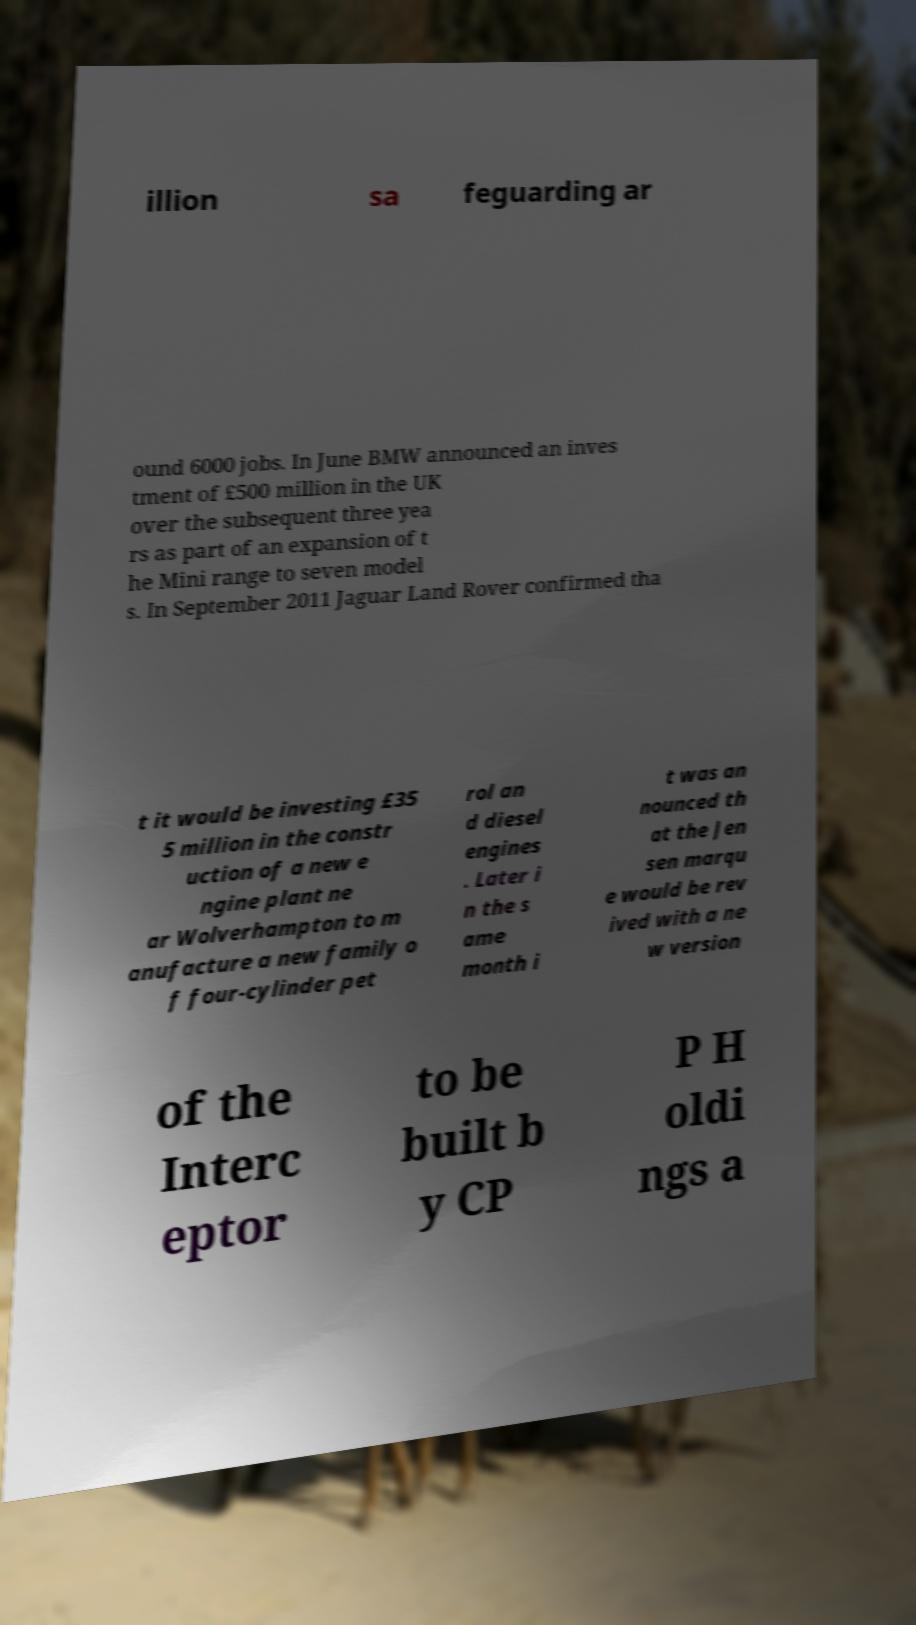Could you extract and type out the text from this image? illion sa feguarding ar ound 6000 jobs. In June BMW announced an inves tment of £500 million in the UK over the subsequent three yea rs as part of an expansion of t he Mini range to seven model s. In September 2011 Jaguar Land Rover confirmed tha t it would be investing £35 5 million in the constr uction of a new e ngine plant ne ar Wolverhampton to m anufacture a new family o f four-cylinder pet rol an d diesel engines . Later i n the s ame month i t was an nounced th at the Jen sen marqu e would be rev ived with a ne w version of the Interc eptor to be built b y CP P H oldi ngs a 